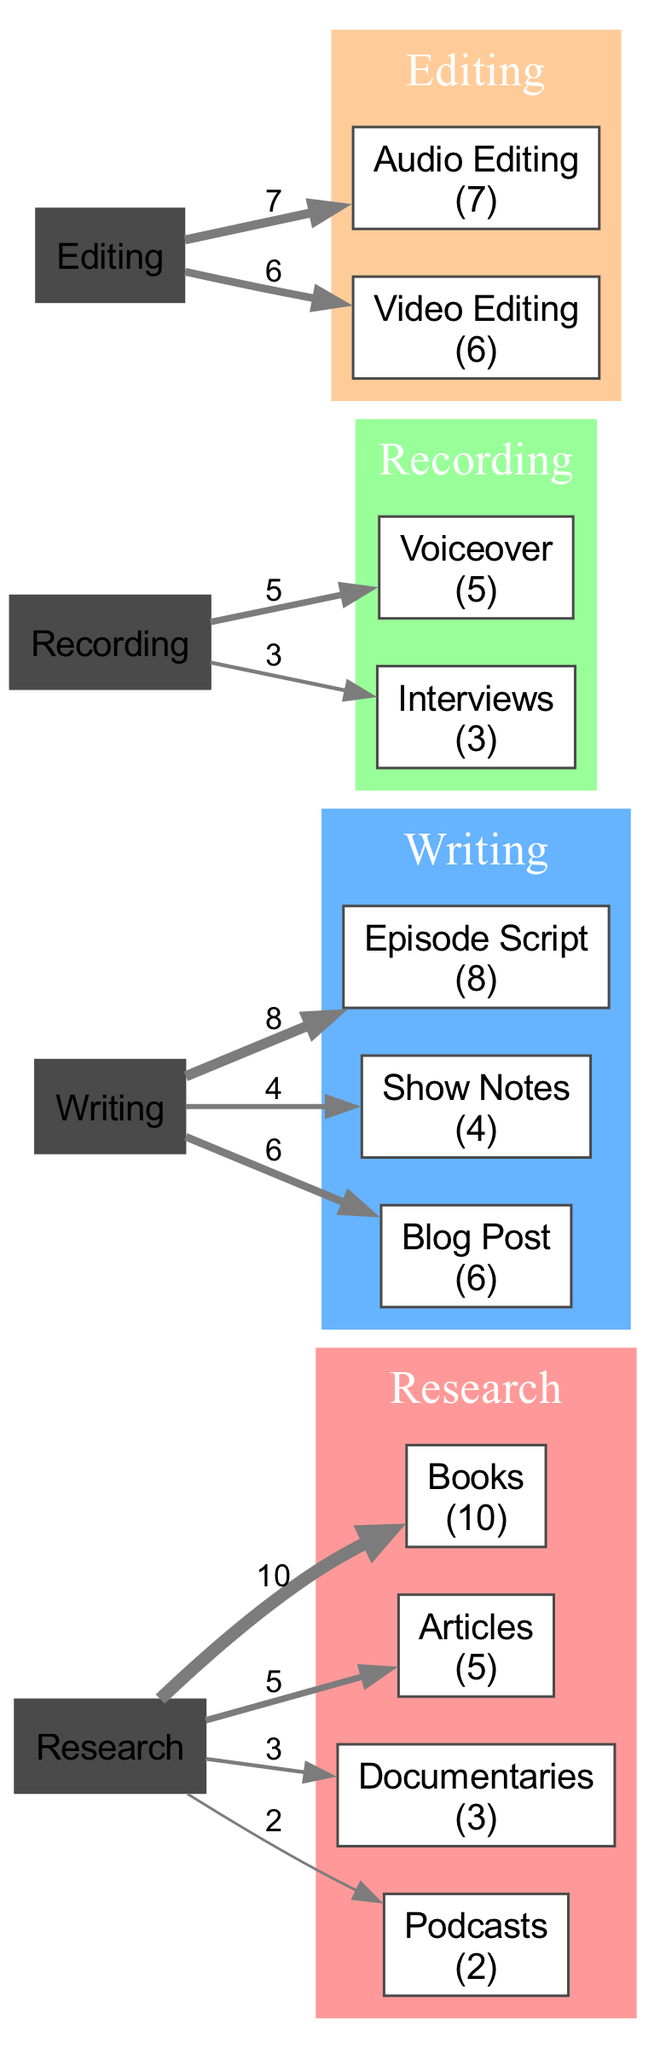What is the total time spent on Research? To find the total time spent on Research, we add together all the values related to Research: 10 (Books) + 5 (Articles) + 3 (Documentaries) + 2 (Podcasts) = 20.
Answer: 20 Which category has the highest time allocation for its tasks? By examining the time allocations of each category, Research is 20, Writing is 18, Recording is 8, and Editing is 13. The maximum is 20, which belongs to Research.
Answer: Research What is the contribution of Interviews to the total Recording time? Interviews represent the amount of time spent on a task within the Recording category, which is 3. The total Recording time is 5 (Voiceover) + 3 (Interviews) = 8.
Answer: 3 How many elements are present in the Writing category? The Writing category consists of three tasks: Episode Script, Show Notes, and Blog Post. Thus, the count of elements in this category is 3.
Answer: 3 What is the ratio of Audio Editing to Video Editing? Audio Editing is allocated 7 units of time, while Video Editing is allocated 6 units. The ratio can be calculated by dividing 7 by 6, resulting in approximately 1.17.
Answer: 1.17 Which task requires more time, Blog Post or Show Notes? Blog Post requires 6 units, while Show Notes require 4 units. By comparison, Blog Post requires more time than Show Notes.
Answer: Blog Post What percentage of the total time spent in Research is dedicated to Documentaries? The total time in Research is 20. Documentaries take 3 of those units. Thus, we calculate the percentage as (3/20) * 100 = 15%.
Answer: 15% How does the total time of Editing compare to Writing? The total time for Editing is 13 (7 for Audio Editing and 6 for Video Editing), while Writing totals to 18. Comparing these, we see that Writing has a higher total time than Editing.
Answer: Writing What is the total flow from the Writing category to its tasks? In the Writing category, the individual task flows are 8 (Episode Script) + 4 (Show Notes) + 6 (Blog Post), giving a total flow of 18.
Answer: 18 